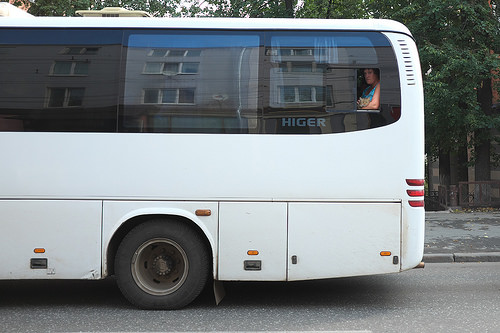<image>
Is the bus in the road? Yes. The bus is contained within or inside the road, showing a containment relationship. 